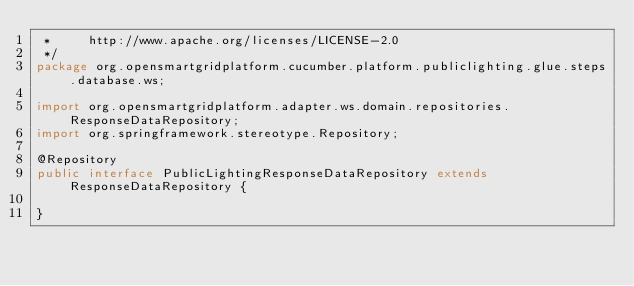Convert code to text. <code><loc_0><loc_0><loc_500><loc_500><_Java_> *     http://www.apache.org/licenses/LICENSE-2.0
 */
package org.opensmartgridplatform.cucumber.platform.publiclighting.glue.steps.database.ws;

import org.opensmartgridplatform.adapter.ws.domain.repositories.ResponseDataRepository;
import org.springframework.stereotype.Repository;

@Repository
public interface PublicLightingResponseDataRepository extends ResponseDataRepository {

}
</code> 